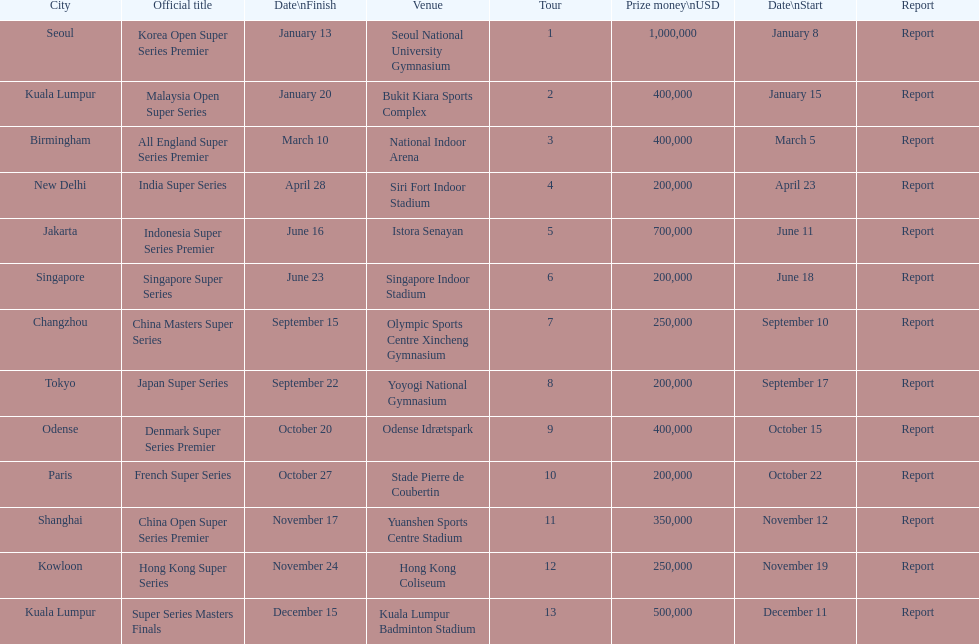How many events of the 2013 bwf super series pay over $200,000? 9. 